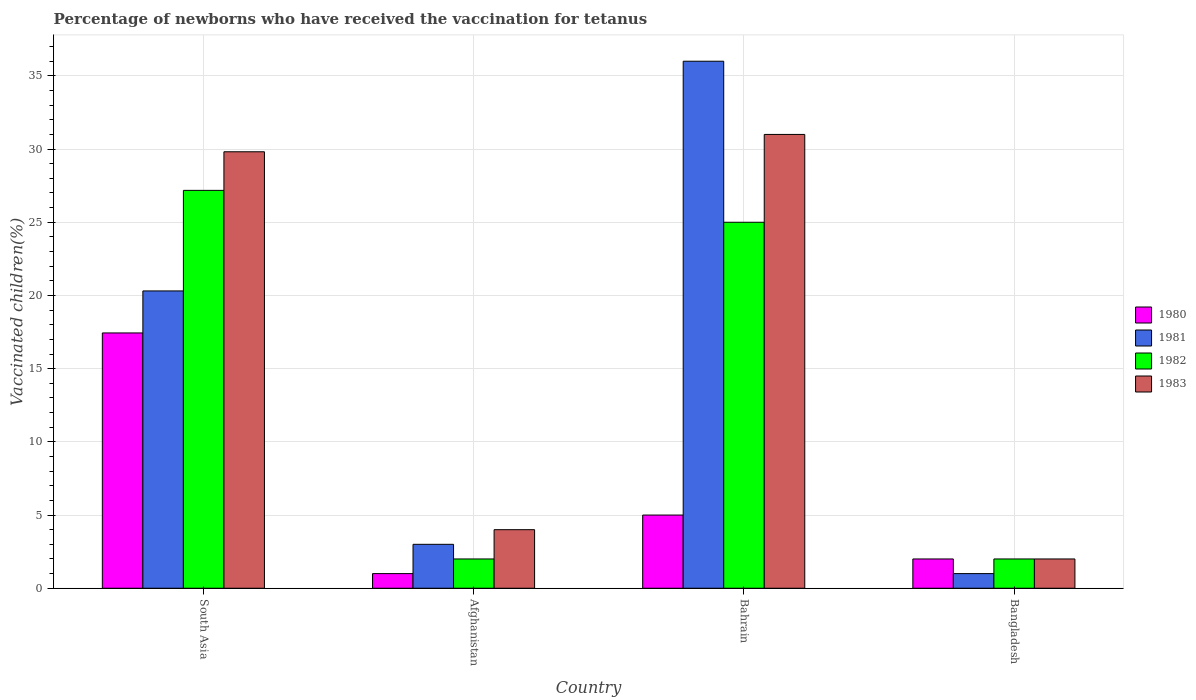Are the number of bars on each tick of the X-axis equal?
Make the answer very short. Yes. How many bars are there on the 3rd tick from the left?
Provide a succinct answer. 4. What is the label of the 2nd group of bars from the left?
Your answer should be very brief. Afghanistan. In how many cases, is the number of bars for a given country not equal to the number of legend labels?
Keep it short and to the point. 0. What is the percentage of vaccinated children in 1980 in South Asia?
Give a very brief answer. 17.44. Across all countries, what is the maximum percentage of vaccinated children in 1982?
Ensure brevity in your answer.  27.18. In which country was the percentage of vaccinated children in 1981 maximum?
Ensure brevity in your answer.  Bahrain. In which country was the percentage of vaccinated children in 1981 minimum?
Ensure brevity in your answer.  Bangladesh. What is the total percentage of vaccinated children in 1980 in the graph?
Keep it short and to the point. 25.44. What is the difference between the percentage of vaccinated children in 1981 in Afghanistan and the percentage of vaccinated children in 1983 in Bahrain?
Keep it short and to the point. -28. What is the average percentage of vaccinated children in 1982 per country?
Your response must be concise. 14.04. What is the ratio of the percentage of vaccinated children in 1983 in Bahrain to that in South Asia?
Your answer should be very brief. 1.04. Is the percentage of vaccinated children in 1982 in Afghanistan less than that in South Asia?
Ensure brevity in your answer.  Yes. Is the difference between the percentage of vaccinated children in 1982 in Afghanistan and South Asia greater than the difference between the percentage of vaccinated children in 1983 in Afghanistan and South Asia?
Offer a terse response. Yes. What is the difference between the highest and the second highest percentage of vaccinated children in 1980?
Give a very brief answer. 15.44. What is the difference between the highest and the lowest percentage of vaccinated children in 1980?
Offer a very short reply. 16.44. What does the 3rd bar from the right in Bangladesh represents?
Make the answer very short. 1981. Is it the case that in every country, the sum of the percentage of vaccinated children in 1983 and percentage of vaccinated children in 1980 is greater than the percentage of vaccinated children in 1982?
Make the answer very short. Yes. How many bars are there?
Make the answer very short. 16. What is the difference between two consecutive major ticks on the Y-axis?
Make the answer very short. 5. Does the graph contain any zero values?
Your answer should be very brief. No. How many legend labels are there?
Provide a short and direct response. 4. What is the title of the graph?
Provide a succinct answer. Percentage of newborns who have received the vaccination for tetanus. What is the label or title of the Y-axis?
Offer a very short reply. Vaccinated children(%). What is the Vaccinated children(%) of 1980 in South Asia?
Your answer should be very brief. 17.44. What is the Vaccinated children(%) of 1981 in South Asia?
Offer a very short reply. 20.31. What is the Vaccinated children(%) of 1982 in South Asia?
Ensure brevity in your answer.  27.18. What is the Vaccinated children(%) in 1983 in South Asia?
Make the answer very short. 29.81. What is the Vaccinated children(%) in 1980 in Afghanistan?
Your response must be concise. 1. What is the Vaccinated children(%) of 1981 in Afghanistan?
Your response must be concise. 3. What is the Vaccinated children(%) in 1982 in Afghanistan?
Your answer should be very brief. 2. What is the Vaccinated children(%) in 1980 in Bahrain?
Give a very brief answer. 5. What is the Vaccinated children(%) in 1981 in Bahrain?
Your answer should be very brief. 36. What is the Vaccinated children(%) of 1982 in Bahrain?
Provide a short and direct response. 25. What is the Vaccinated children(%) of 1980 in Bangladesh?
Ensure brevity in your answer.  2. What is the Vaccinated children(%) in 1981 in Bangladesh?
Offer a terse response. 1. What is the Vaccinated children(%) in 1983 in Bangladesh?
Keep it short and to the point. 2. Across all countries, what is the maximum Vaccinated children(%) of 1980?
Your answer should be very brief. 17.44. Across all countries, what is the maximum Vaccinated children(%) of 1981?
Your answer should be very brief. 36. Across all countries, what is the maximum Vaccinated children(%) in 1982?
Your answer should be compact. 27.18. Across all countries, what is the maximum Vaccinated children(%) in 1983?
Your answer should be very brief. 31. Across all countries, what is the minimum Vaccinated children(%) of 1981?
Provide a short and direct response. 1. Across all countries, what is the minimum Vaccinated children(%) of 1982?
Ensure brevity in your answer.  2. What is the total Vaccinated children(%) in 1980 in the graph?
Your answer should be very brief. 25.44. What is the total Vaccinated children(%) in 1981 in the graph?
Your answer should be compact. 60.31. What is the total Vaccinated children(%) in 1982 in the graph?
Give a very brief answer. 56.18. What is the total Vaccinated children(%) in 1983 in the graph?
Keep it short and to the point. 66.81. What is the difference between the Vaccinated children(%) in 1980 in South Asia and that in Afghanistan?
Offer a terse response. 16.44. What is the difference between the Vaccinated children(%) in 1981 in South Asia and that in Afghanistan?
Your answer should be very brief. 17.31. What is the difference between the Vaccinated children(%) of 1982 in South Asia and that in Afghanistan?
Make the answer very short. 25.18. What is the difference between the Vaccinated children(%) of 1983 in South Asia and that in Afghanistan?
Ensure brevity in your answer.  25.81. What is the difference between the Vaccinated children(%) in 1980 in South Asia and that in Bahrain?
Provide a succinct answer. 12.44. What is the difference between the Vaccinated children(%) in 1981 in South Asia and that in Bahrain?
Offer a terse response. -15.69. What is the difference between the Vaccinated children(%) of 1982 in South Asia and that in Bahrain?
Provide a short and direct response. 2.18. What is the difference between the Vaccinated children(%) in 1983 in South Asia and that in Bahrain?
Provide a short and direct response. -1.19. What is the difference between the Vaccinated children(%) in 1980 in South Asia and that in Bangladesh?
Provide a short and direct response. 15.44. What is the difference between the Vaccinated children(%) of 1981 in South Asia and that in Bangladesh?
Offer a very short reply. 19.31. What is the difference between the Vaccinated children(%) of 1982 in South Asia and that in Bangladesh?
Give a very brief answer. 25.18. What is the difference between the Vaccinated children(%) in 1983 in South Asia and that in Bangladesh?
Your answer should be very brief. 27.81. What is the difference between the Vaccinated children(%) in 1981 in Afghanistan and that in Bahrain?
Your response must be concise. -33. What is the difference between the Vaccinated children(%) of 1983 in Afghanistan and that in Bahrain?
Keep it short and to the point. -27. What is the difference between the Vaccinated children(%) in 1982 in Afghanistan and that in Bangladesh?
Provide a short and direct response. 0. What is the difference between the Vaccinated children(%) in 1983 in Afghanistan and that in Bangladesh?
Give a very brief answer. 2. What is the difference between the Vaccinated children(%) of 1981 in Bahrain and that in Bangladesh?
Your answer should be very brief. 35. What is the difference between the Vaccinated children(%) in 1983 in Bahrain and that in Bangladesh?
Provide a succinct answer. 29. What is the difference between the Vaccinated children(%) of 1980 in South Asia and the Vaccinated children(%) of 1981 in Afghanistan?
Offer a terse response. 14.44. What is the difference between the Vaccinated children(%) of 1980 in South Asia and the Vaccinated children(%) of 1982 in Afghanistan?
Ensure brevity in your answer.  15.44. What is the difference between the Vaccinated children(%) in 1980 in South Asia and the Vaccinated children(%) in 1983 in Afghanistan?
Ensure brevity in your answer.  13.44. What is the difference between the Vaccinated children(%) of 1981 in South Asia and the Vaccinated children(%) of 1982 in Afghanistan?
Provide a succinct answer. 18.31. What is the difference between the Vaccinated children(%) in 1981 in South Asia and the Vaccinated children(%) in 1983 in Afghanistan?
Your answer should be very brief. 16.31. What is the difference between the Vaccinated children(%) in 1982 in South Asia and the Vaccinated children(%) in 1983 in Afghanistan?
Keep it short and to the point. 23.18. What is the difference between the Vaccinated children(%) in 1980 in South Asia and the Vaccinated children(%) in 1981 in Bahrain?
Your answer should be compact. -18.56. What is the difference between the Vaccinated children(%) of 1980 in South Asia and the Vaccinated children(%) of 1982 in Bahrain?
Offer a very short reply. -7.56. What is the difference between the Vaccinated children(%) in 1980 in South Asia and the Vaccinated children(%) in 1983 in Bahrain?
Provide a short and direct response. -13.56. What is the difference between the Vaccinated children(%) of 1981 in South Asia and the Vaccinated children(%) of 1982 in Bahrain?
Your answer should be compact. -4.69. What is the difference between the Vaccinated children(%) of 1981 in South Asia and the Vaccinated children(%) of 1983 in Bahrain?
Your answer should be very brief. -10.69. What is the difference between the Vaccinated children(%) in 1982 in South Asia and the Vaccinated children(%) in 1983 in Bahrain?
Provide a succinct answer. -3.82. What is the difference between the Vaccinated children(%) of 1980 in South Asia and the Vaccinated children(%) of 1981 in Bangladesh?
Make the answer very short. 16.44. What is the difference between the Vaccinated children(%) in 1980 in South Asia and the Vaccinated children(%) in 1982 in Bangladesh?
Keep it short and to the point. 15.44. What is the difference between the Vaccinated children(%) of 1980 in South Asia and the Vaccinated children(%) of 1983 in Bangladesh?
Make the answer very short. 15.44. What is the difference between the Vaccinated children(%) of 1981 in South Asia and the Vaccinated children(%) of 1982 in Bangladesh?
Keep it short and to the point. 18.31. What is the difference between the Vaccinated children(%) in 1981 in South Asia and the Vaccinated children(%) in 1983 in Bangladesh?
Ensure brevity in your answer.  18.31. What is the difference between the Vaccinated children(%) in 1982 in South Asia and the Vaccinated children(%) in 1983 in Bangladesh?
Offer a terse response. 25.18. What is the difference between the Vaccinated children(%) in 1980 in Afghanistan and the Vaccinated children(%) in 1981 in Bahrain?
Give a very brief answer. -35. What is the difference between the Vaccinated children(%) in 1980 in Afghanistan and the Vaccinated children(%) in 1982 in Bahrain?
Make the answer very short. -24. What is the difference between the Vaccinated children(%) of 1980 in Afghanistan and the Vaccinated children(%) of 1983 in Bahrain?
Ensure brevity in your answer.  -30. What is the difference between the Vaccinated children(%) of 1981 in Afghanistan and the Vaccinated children(%) of 1983 in Bahrain?
Provide a succinct answer. -28. What is the difference between the Vaccinated children(%) in 1982 in Afghanistan and the Vaccinated children(%) in 1983 in Bahrain?
Keep it short and to the point. -29. What is the difference between the Vaccinated children(%) of 1980 in Afghanistan and the Vaccinated children(%) of 1981 in Bangladesh?
Provide a short and direct response. 0. What is the difference between the Vaccinated children(%) of 1980 in Afghanistan and the Vaccinated children(%) of 1982 in Bangladesh?
Offer a terse response. -1. What is the difference between the Vaccinated children(%) in 1981 in Afghanistan and the Vaccinated children(%) in 1982 in Bangladesh?
Offer a very short reply. 1. What is the difference between the Vaccinated children(%) of 1982 in Afghanistan and the Vaccinated children(%) of 1983 in Bangladesh?
Provide a short and direct response. 0. What is the difference between the Vaccinated children(%) in 1980 in Bahrain and the Vaccinated children(%) in 1981 in Bangladesh?
Provide a succinct answer. 4. What is the difference between the Vaccinated children(%) in 1980 in Bahrain and the Vaccinated children(%) in 1982 in Bangladesh?
Make the answer very short. 3. What is the difference between the Vaccinated children(%) of 1980 in Bahrain and the Vaccinated children(%) of 1983 in Bangladesh?
Your answer should be compact. 3. What is the difference between the Vaccinated children(%) in 1981 in Bahrain and the Vaccinated children(%) in 1983 in Bangladesh?
Keep it short and to the point. 34. What is the average Vaccinated children(%) of 1980 per country?
Ensure brevity in your answer.  6.36. What is the average Vaccinated children(%) of 1981 per country?
Your answer should be very brief. 15.08. What is the average Vaccinated children(%) in 1982 per country?
Give a very brief answer. 14.04. What is the average Vaccinated children(%) in 1983 per country?
Offer a very short reply. 16.7. What is the difference between the Vaccinated children(%) in 1980 and Vaccinated children(%) in 1981 in South Asia?
Ensure brevity in your answer.  -2.87. What is the difference between the Vaccinated children(%) in 1980 and Vaccinated children(%) in 1982 in South Asia?
Your response must be concise. -9.74. What is the difference between the Vaccinated children(%) in 1980 and Vaccinated children(%) in 1983 in South Asia?
Your answer should be compact. -12.37. What is the difference between the Vaccinated children(%) in 1981 and Vaccinated children(%) in 1982 in South Asia?
Your answer should be compact. -6.87. What is the difference between the Vaccinated children(%) in 1981 and Vaccinated children(%) in 1983 in South Asia?
Your answer should be very brief. -9.51. What is the difference between the Vaccinated children(%) of 1982 and Vaccinated children(%) of 1983 in South Asia?
Offer a very short reply. -2.64. What is the difference between the Vaccinated children(%) of 1980 and Vaccinated children(%) of 1983 in Afghanistan?
Give a very brief answer. -3. What is the difference between the Vaccinated children(%) in 1982 and Vaccinated children(%) in 1983 in Afghanistan?
Your response must be concise. -2. What is the difference between the Vaccinated children(%) in 1980 and Vaccinated children(%) in 1981 in Bahrain?
Keep it short and to the point. -31. What is the difference between the Vaccinated children(%) of 1980 and Vaccinated children(%) of 1982 in Bahrain?
Offer a terse response. -20. What is the difference between the Vaccinated children(%) in 1981 and Vaccinated children(%) in 1983 in Bahrain?
Make the answer very short. 5. What is the difference between the Vaccinated children(%) of 1982 and Vaccinated children(%) of 1983 in Bahrain?
Offer a very short reply. -6. What is the difference between the Vaccinated children(%) of 1981 and Vaccinated children(%) of 1982 in Bangladesh?
Your response must be concise. -1. What is the difference between the Vaccinated children(%) of 1982 and Vaccinated children(%) of 1983 in Bangladesh?
Provide a succinct answer. 0. What is the ratio of the Vaccinated children(%) in 1980 in South Asia to that in Afghanistan?
Make the answer very short. 17.44. What is the ratio of the Vaccinated children(%) in 1981 in South Asia to that in Afghanistan?
Make the answer very short. 6.77. What is the ratio of the Vaccinated children(%) of 1982 in South Asia to that in Afghanistan?
Your answer should be very brief. 13.59. What is the ratio of the Vaccinated children(%) in 1983 in South Asia to that in Afghanistan?
Offer a terse response. 7.45. What is the ratio of the Vaccinated children(%) in 1980 in South Asia to that in Bahrain?
Your response must be concise. 3.49. What is the ratio of the Vaccinated children(%) of 1981 in South Asia to that in Bahrain?
Your answer should be very brief. 0.56. What is the ratio of the Vaccinated children(%) in 1982 in South Asia to that in Bahrain?
Ensure brevity in your answer.  1.09. What is the ratio of the Vaccinated children(%) of 1983 in South Asia to that in Bahrain?
Your response must be concise. 0.96. What is the ratio of the Vaccinated children(%) in 1980 in South Asia to that in Bangladesh?
Your response must be concise. 8.72. What is the ratio of the Vaccinated children(%) of 1981 in South Asia to that in Bangladesh?
Provide a short and direct response. 20.31. What is the ratio of the Vaccinated children(%) of 1982 in South Asia to that in Bangladesh?
Keep it short and to the point. 13.59. What is the ratio of the Vaccinated children(%) of 1983 in South Asia to that in Bangladesh?
Your response must be concise. 14.91. What is the ratio of the Vaccinated children(%) of 1980 in Afghanistan to that in Bahrain?
Offer a terse response. 0.2. What is the ratio of the Vaccinated children(%) of 1981 in Afghanistan to that in Bahrain?
Give a very brief answer. 0.08. What is the ratio of the Vaccinated children(%) of 1982 in Afghanistan to that in Bahrain?
Your answer should be very brief. 0.08. What is the ratio of the Vaccinated children(%) in 1983 in Afghanistan to that in Bahrain?
Your response must be concise. 0.13. What is the ratio of the Vaccinated children(%) in 1980 in Afghanistan to that in Bangladesh?
Provide a succinct answer. 0.5. What is the ratio of the Vaccinated children(%) in 1981 in Afghanistan to that in Bangladesh?
Offer a very short reply. 3. What is the ratio of the Vaccinated children(%) of 1982 in Bahrain to that in Bangladesh?
Offer a very short reply. 12.5. What is the difference between the highest and the second highest Vaccinated children(%) in 1980?
Give a very brief answer. 12.44. What is the difference between the highest and the second highest Vaccinated children(%) in 1981?
Offer a very short reply. 15.69. What is the difference between the highest and the second highest Vaccinated children(%) in 1982?
Offer a very short reply. 2.18. What is the difference between the highest and the second highest Vaccinated children(%) in 1983?
Your answer should be very brief. 1.19. What is the difference between the highest and the lowest Vaccinated children(%) of 1980?
Keep it short and to the point. 16.44. What is the difference between the highest and the lowest Vaccinated children(%) of 1982?
Give a very brief answer. 25.18. 